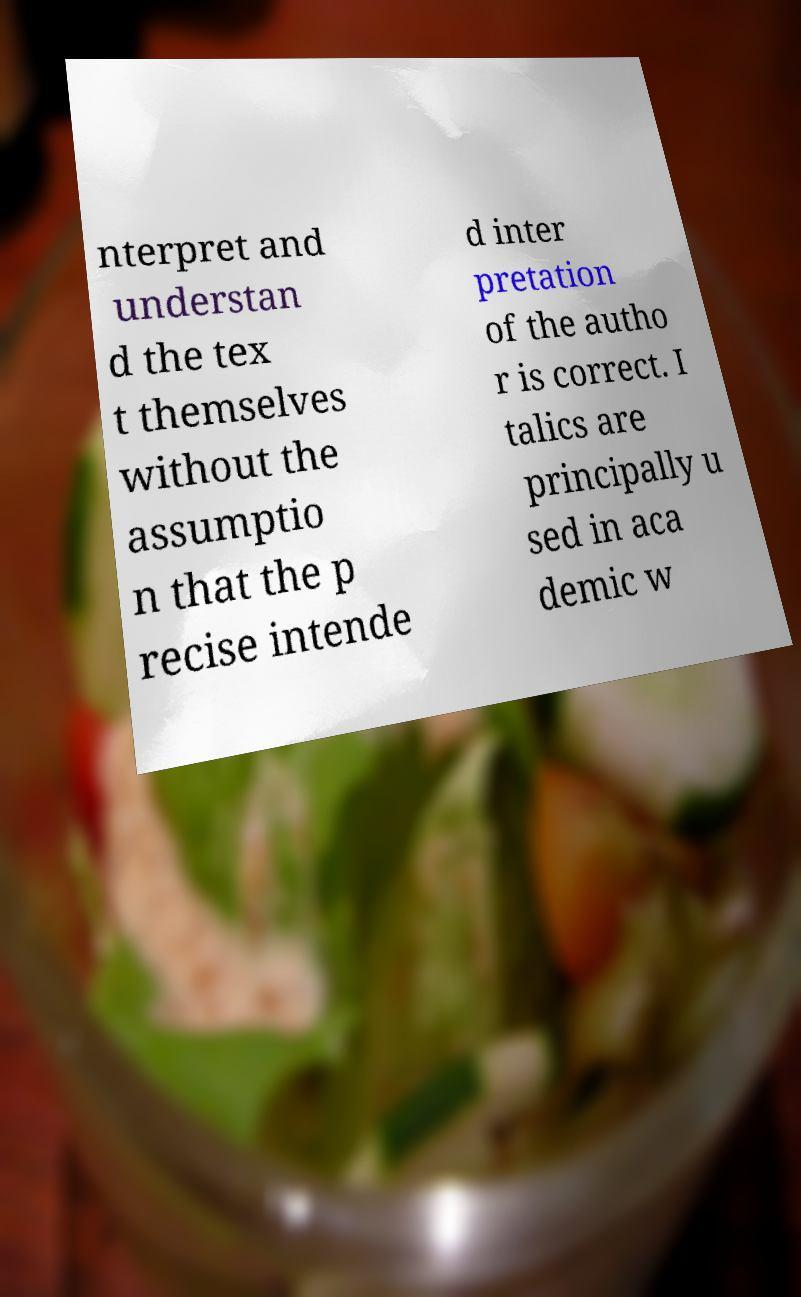Please read and relay the text visible in this image. What does it say? nterpret and understan d the tex t themselves without the assumptio n that the p recise intende d inter pretation of the autho r is correct. I talics are principally u sed in aca demic w 